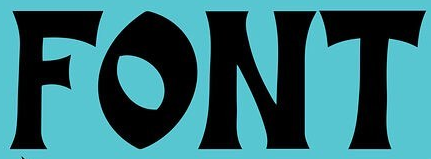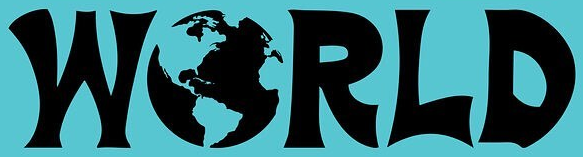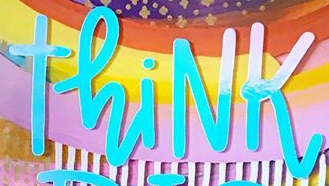Read the text from these images in sequence, separated by a semicolon. FONT; WORLD; ThiNK 